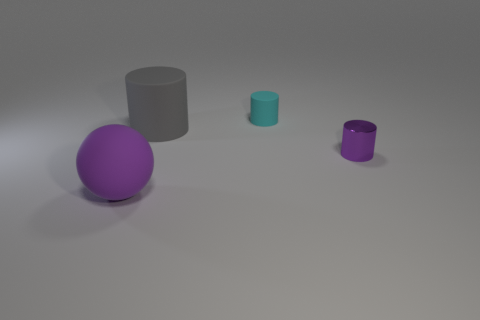Add 1 large matte spheres. How many objects exist? 5 Subtract all cylinders. How many objects are left? 1 Subtract all tiny metal things. Subtract all purple matte spheres. How many objects are left? 2 Add 2 matte cylinders. How many matte cylinders are left? 4 Add 1 small purple shiny cylinders. How many small purple shiny cylinders exist? 2 Subtract 0 green blocks. How many objects are left? 4 